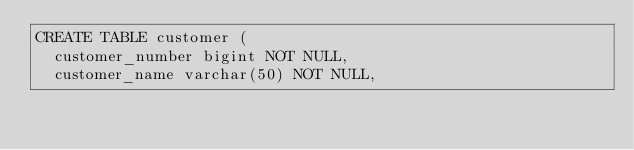<code> <loc_0><loc_0><loc_500><loc_500><_SQL_>CREATE TABLE customer (
  customer_number bigint NOT NULL,
  customer_name varchar(50) NOT NULL,</code> 